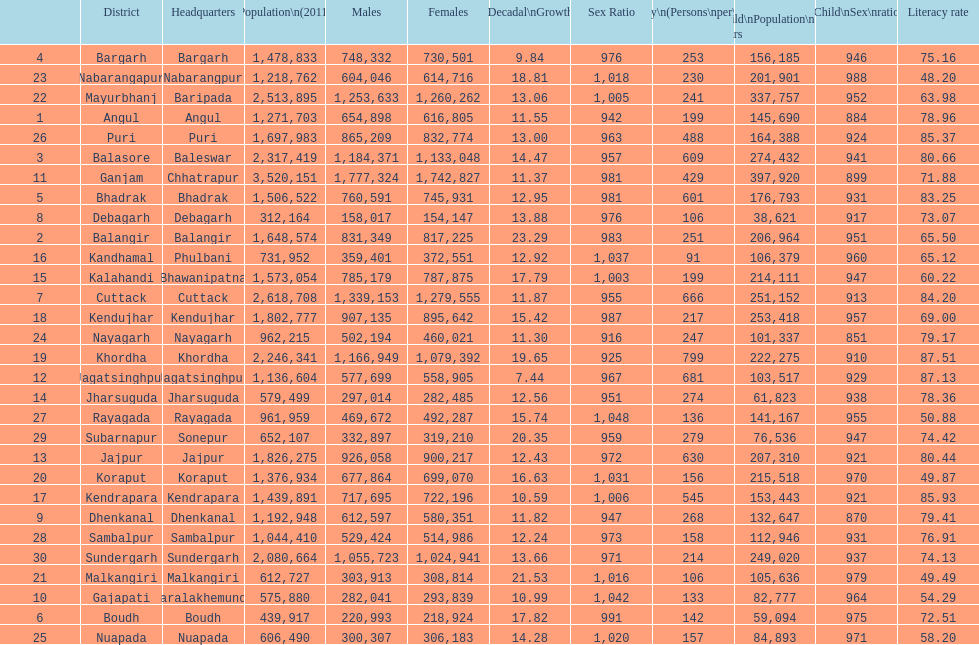What is the number of females residing in cuttack? 1,279,555. 